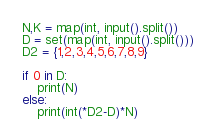Convert code to text. <code><loc_0><loc_0><loc_500><loc_500><_Python_>N,K = map(int, input().split())
D = set(map(int, input().split()))
D2 = {1,2,3,4,5,6,7,8,9}

if 0 in D:
    print(N)
else:
    print(int(*D2-D)*N)</code> 